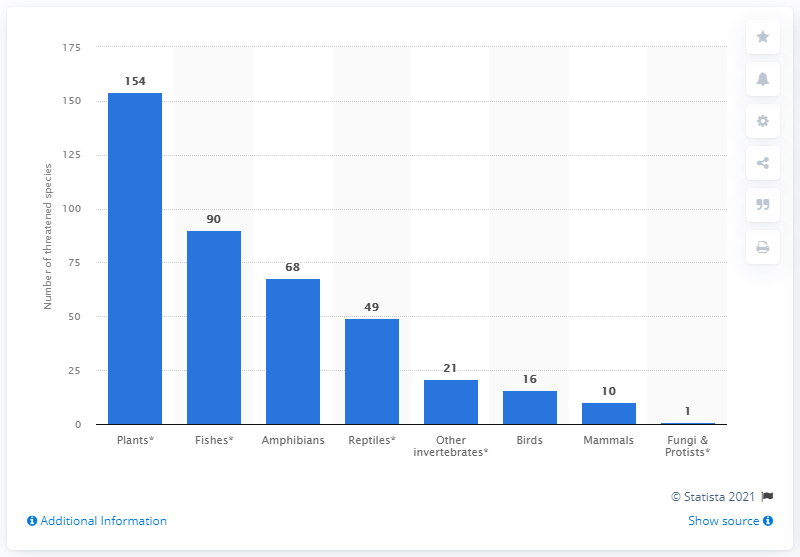List a handful of essential elements in this visual. In 2021, the Red List in Honduras contained 154 plants. In Honduras, an alarming 90 fish species are under threat, highlighting the urgent need for conservation efforts to protect biodiversity and sustainable fishing practices. 